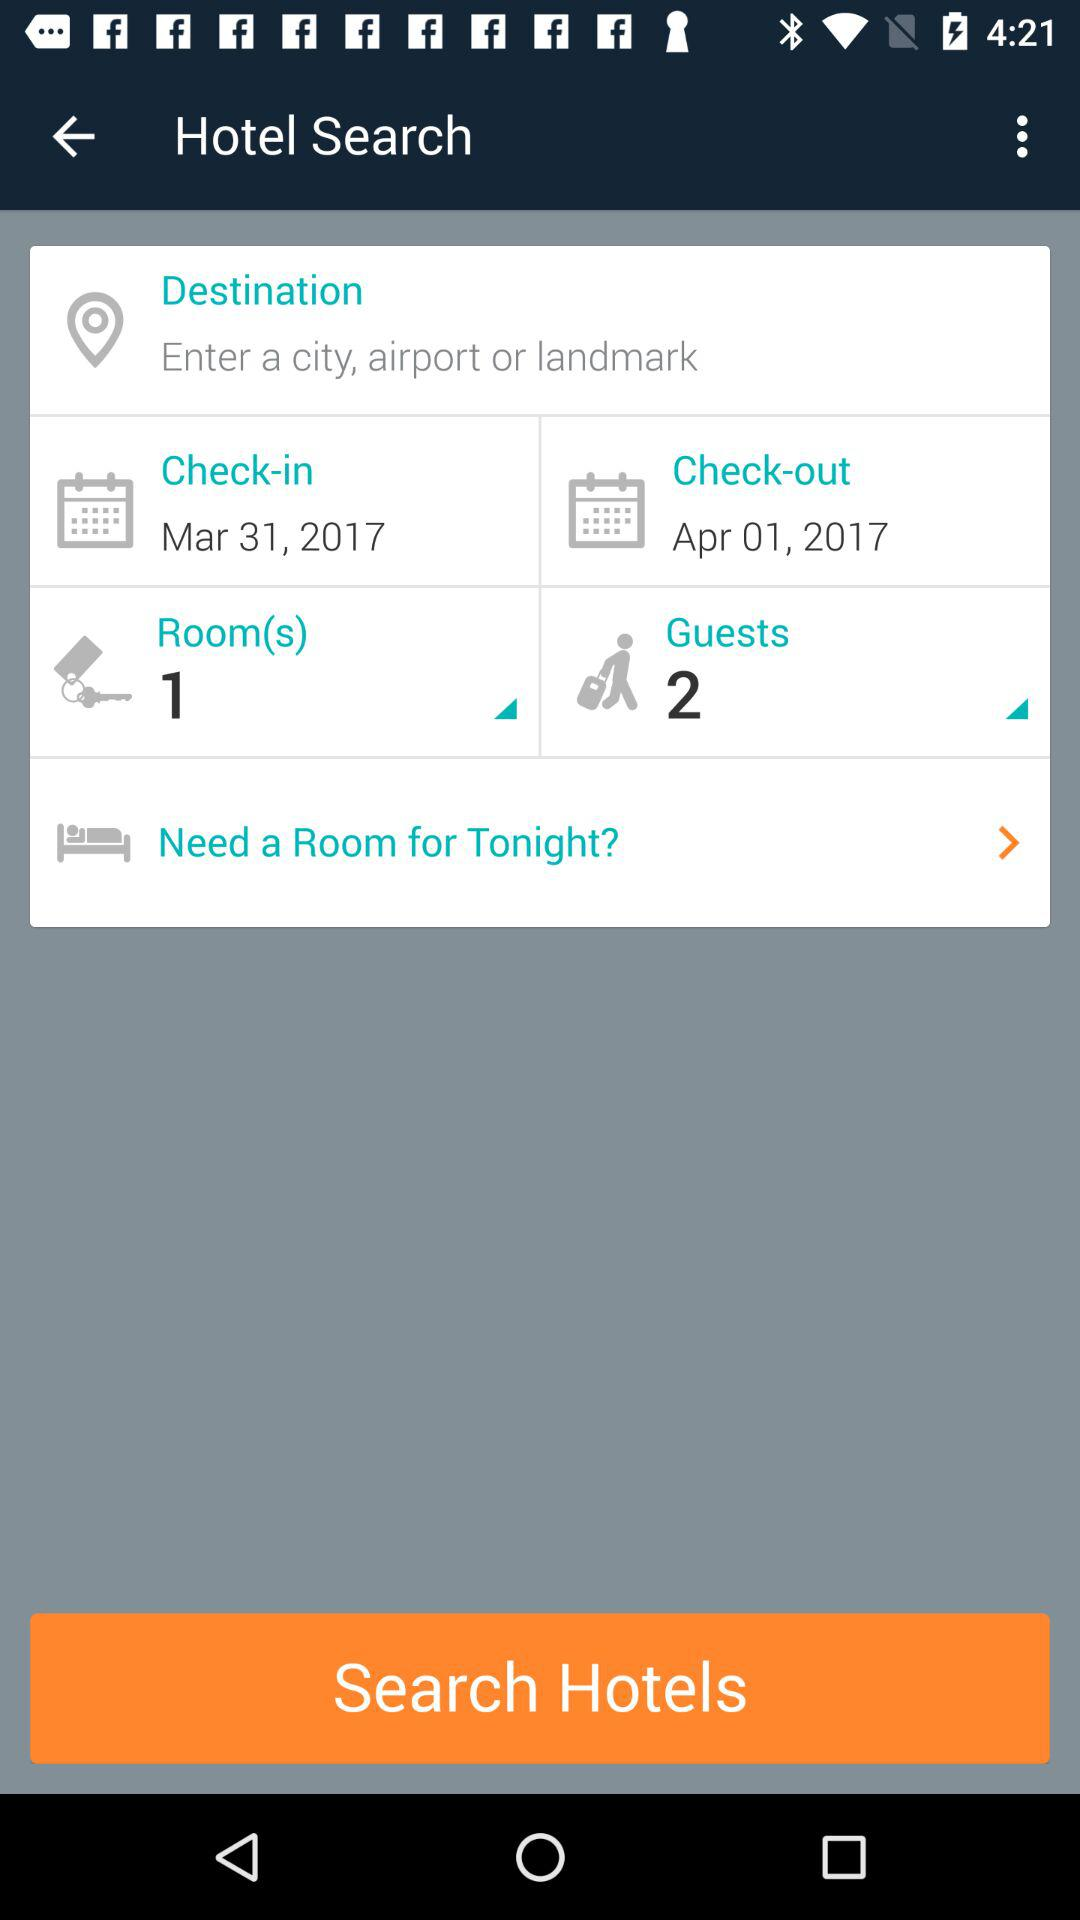How many more people are staying than rooms?
Answer the question using a single word or phrase. 1 